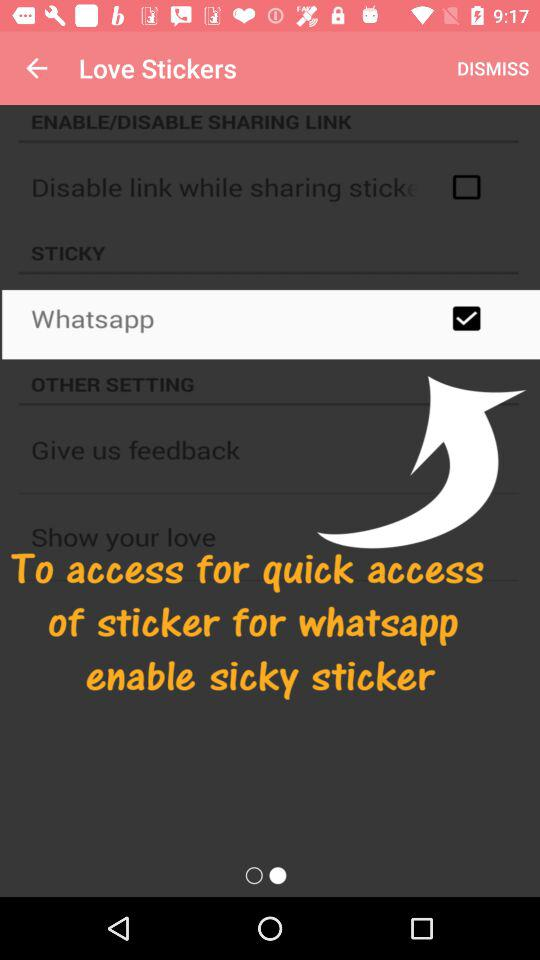What is the status of "Whatsapp"? The status of "Whatsapp" is "on". 